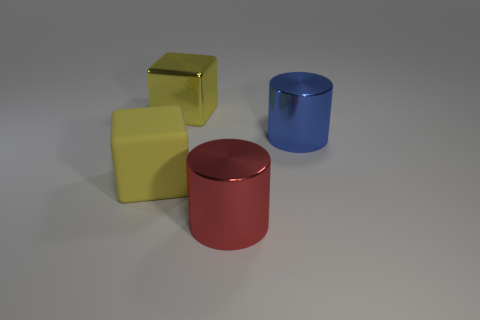The big thing that is both in front of the blue shiny cylinder and behind the large red metallic cylinder is made of what material?
Provide a succinct answer. Rubber. What is the size of the metal thing that is the same color as the big rubber cube?
Offer a terse response. Large. There is a object right of the large red metal thing that is on the right side of the big matte block; what is its material?
Offer a terse response. Metal. How big is the thing behind the cylinder that is behind the big metallic cylinder that is in front of the large yellow matte cube?
Offer a terse response. Large. How many small brown balls have the same material as the large red cylinder?
Provide a succinct answer. 0. There is a big cube in front of the big metallic object on the right side of the big red shiny object; what is its color?
Offer a terse response. Yellow. What number of things are either metal cubes or large yellow things left of the yellow metallic block?
Give a very brief answer. 2. Is there a shiny cylinder that has the same color as the large metallic block?
Offer a terse response. No. How many cyan things are either tiny shiny spheres or big rubber blocks?
Offer a very short reply. 0. What number of other objects are the same size as the blue cylinder?
Make the answer very short. 3. 